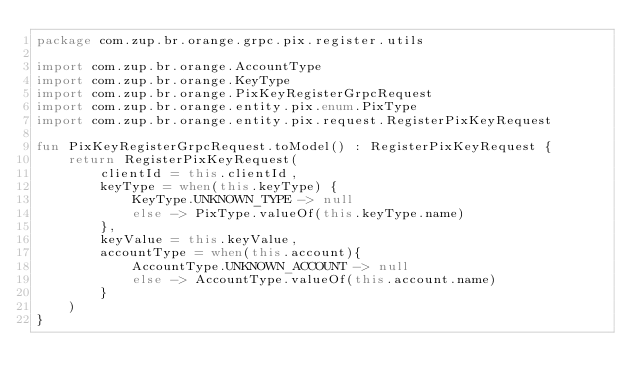Convert code to text. <code><loc_0><loc_0><loc_500><loc_500><_Kotlin_>package com.zup.br.orange.grpc.pix.register.utils

import com.zup.br.orange.AccountType
import com.zup.br.orange.KeyType
import com.zup.br.orange.PixKeyRegisterGrpcRequest
import com.zup.br.orange.entity.pix.enum.PixType
import com.zup.br.orange.entity.pix.request.RegisterPixKeyRequest

fun PixKeyRegisterGrpcRequest.toModel() : RegisterPixKeyRequest {
    return RegisterPixKeyRequest(
        clientId = this.clientId,
        keyType = when(this.keyType) {
            KeyType.UNKNOWN_TYPE -> null
            else -> PixType.valueOf(this.keyType.name)
        },
        keyValue = this.keyValue,
        accountType = when(this.account){
            AccountType.UNKNOWN_ACCOUNT -> null
            else -> AccountType.valueOf(this.account.name)
        }
    )
}</code> 